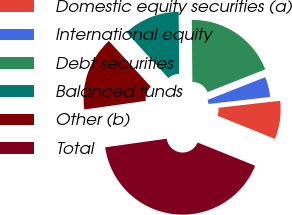Convert chart. <chart><loc_0><loc_0><loc_500><loc_500><pie_chart><fcel>Domestic equity securities (a)<fcel>International equity<fcel>Debt securities<fcel>Balanced funds<fcel>Other (b)<fcel>Total<nl><fcel>7.92%<fcel>4.17%<fcel>19.17%<fcel>11.67%<fcel>15.42%<fcel>41.67%<nl></chart> 